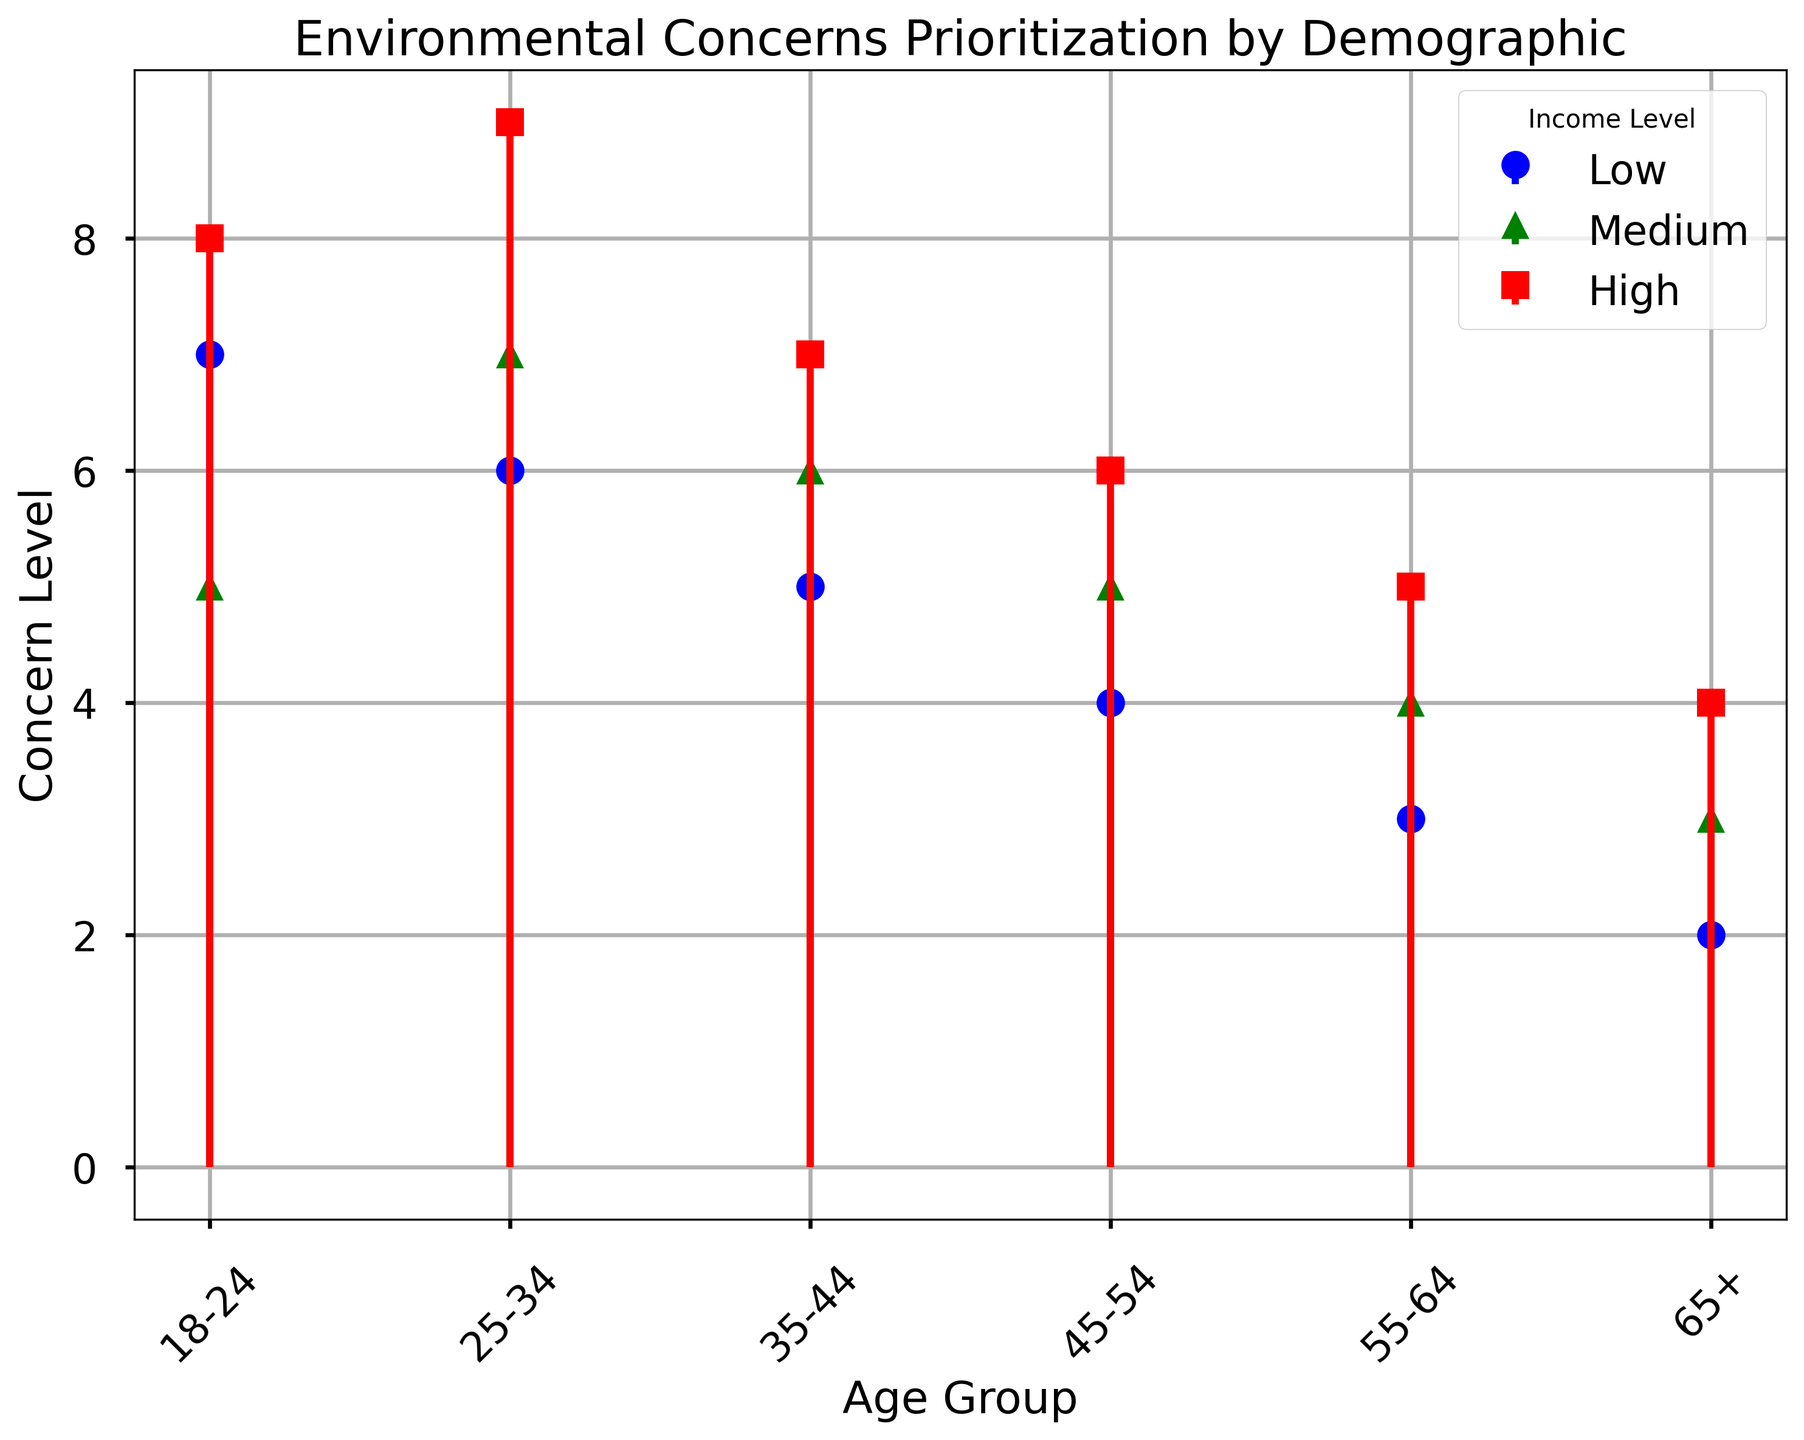How does the concern level trend among different age groups for low-income individuals? The concern level for low-income individuals decreases from 7 in the 18-24 age group to 2 in the 65+ age group.
Answer: It decreases Which income level has the highest concern level within the 25-34 age group? In the 25-34 age group, the high-income level has the highest concern level of 9.
Answer: High Compare the concern levels between high and medium-income levels for the 55-64 age group. Which is higher? For the 55-64 age group, the high-income level has a concern level of 5, while the medium-income level has a concern level of 4. Therefore, the high-income level is higher.
Answer: High What is the average concern level for the 18-24 age group? The concern levels for the 18-24 age group are 7 (low), 5 (medium), and 8 (high). The average is (7 + 5 + 8) / 3 = 20 / 3 ≈ 6.67.
Answer: ~6.67 Among the 35-44 age group, which income level shows the lowest concern level? In the 35-44 age group, the low-income level has the lowest concern level of 5.
Answer: Low Examine the trend in concern levels for high-income individuals across the age groups. How does it change? The concern levels for high-income individuals are 8 (18-24), 9 (25-34), 7 (35-44), 6 (45-54), 5 (55-64), and 4 (65+). The trend shows a decrease as the age increases.
Answer: It decreases Which age group shows the smallest difference in concern levels between high and low-income levels? The 35-44 age group has concern levels of 7 (high) and 5 (low). The difference is 2, which is the smallest among all age groups.
Answer: 35-44 Rank the concern levels for medium-income individuals from highest to lowest across all age groups. The concern levels for medium-income individuals from highest to lowest are: 7 (25-34), 6 (35-44), 5 (18-24 and 45-54), 4 (55-64), 3 (65+).
Answer: 7, 6, 5, 4, 3 What is the total concern level of high-income individuals across all age groups? The concern levels for high-income individuals are 8 (18-24), 9 (25-34), 7 (35-44), 6 (45-54), 5 (55-64), and 4 (65+). The total is 8 + 9 + 7 + 6 + 5 + 4 = 39.
Answer: 39 Which color represents medium-income levels in the plot? The color green represents medium-income levels in the plot.
Answer: Green 